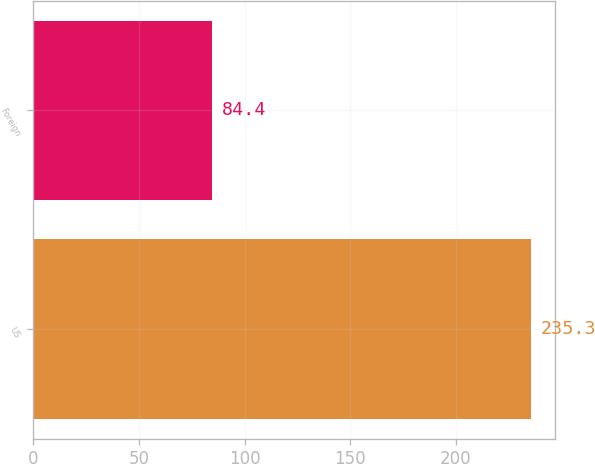Convert chart to OTSL. <chart><loc_0><loc_0><loc_500><loc_500><bar_chart><fcel>US<fcel>Foreign<nl><fcel>235.3<fcel>84.4<nl></chart> 